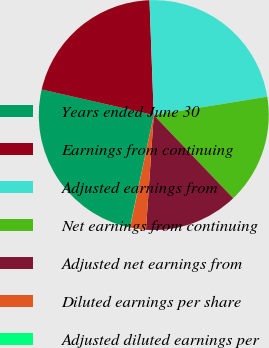Convert chart. <chart><loc_0><loc_0><loc_500><loc_500><pie_chart><fcel>Years ended June 30<fcel>Earnings from continuing<fcel>Adjusted earnings from<fcel>Net earnings from continuing<fcel>Adjusted net earnings from<fcel>Diluted earnings per share<fcel>Adjusted diluted earnings per<nl><fcel>25.24%<fcel>20.84%<fcel>23.04%<fcel>15.42%<fcel>13.22%<fcel>2.23%<fcel>0.03%<nl></chart> 